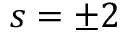Convert formula to latex. <formula><loc_0><loc_0><loc_500><loc_500>s = \pm 2</formula> 